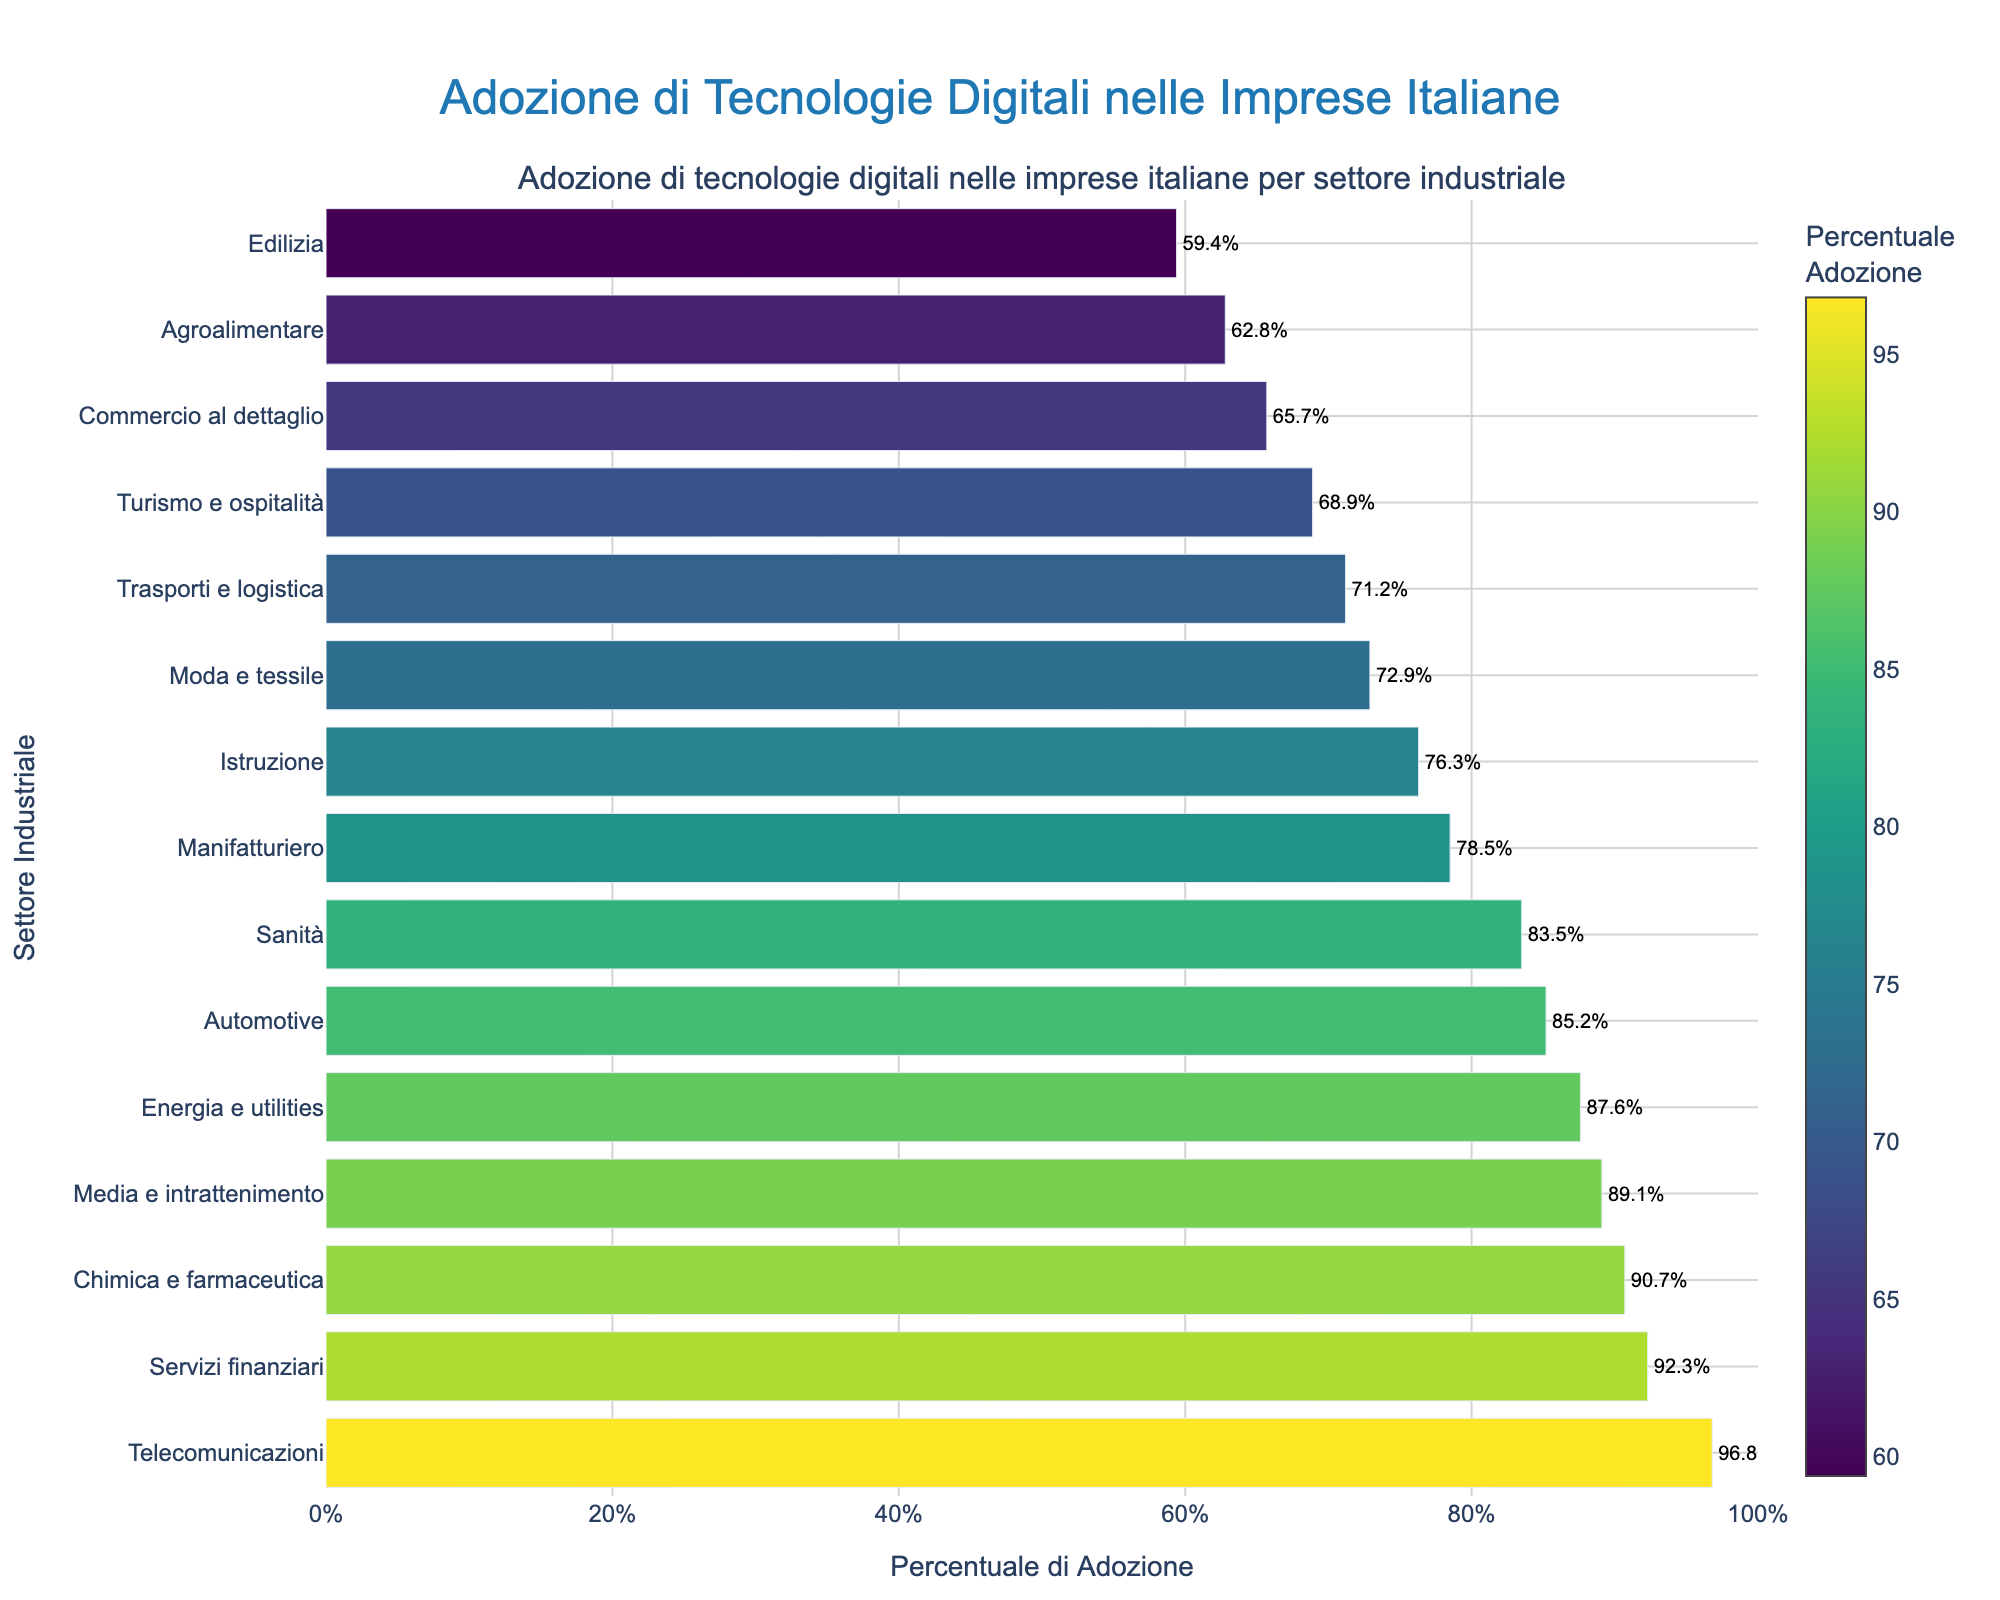Quale settore ha la più alta percentuale di adozione di tecnologie digitali? La barra più lunga e di colore più scuro rappresenta il settore delle Telecomunicazioni, con una percentuale del 96.8%.
Answer: Telecomunicazioni Qual è la differenza percentuale di adozione tra i settori Manifatturiero e Telecomunicazioni? La percentuale di adozione nel Manifatturiero è 78.5%, mentre nelle Telecomunicazioni è 96.8%. La differenza è 96.8% - 78.5% = 18.3%.
Answer: 18.3% Quali settori hanno una percentuale di adozione superiore al 90%? Osservando le barre con percentuali superiori al 90%, i settori sono: Telecomunicazioni (96.8%), Servizi finanziari (92.3%) e Chimica e farmaceutica (90.7%).
Answer: Telecomunicazioni, Servizi finanziari, Chimica e farmaceutica Quale settore presenta la barra più corta e qual è la sua percentuale di adozione? La barra più corta corrisponde all'Edilizia, con una percentuale di adozione del 59.4%.
Answer: Edilizia, 59.4% Quali settori hanno una percentuale di adozione superiore alla media? Per trovare la media, sommiamo tutte le percentuali e dividiamo per il numero di settori: (78.5 + 92.3 + 65.7 + 96.8 + 71.2 + 59.4 + 62.8 + 68.9 + 83.5 + 87.6 + 76.3 + 89.1 + 85.2 + 90.7 + 72.9) / 15 = 77.3%. I settori con una percentuale superiore a questa media sono: Telecomunicazioni, Servizi finanziari, Sanità, Energia e utilities, Media e intrattenimento, Automotive, Chimica e farmaceutica.
Answer: Telecomunicazioni, Servizi finanziari, Sanità, Energia e utilities, Media e intrattenimento, Automotive, Chimica e farmaceutica 